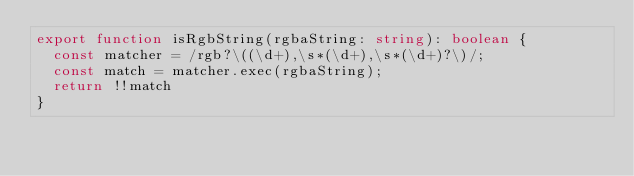<code> <loc_0><loc_0><loc_500><loc_500><_TypeScript_>export function isRgbString(rgbaString: string): boolean {
  const matcher = /rgb?\((\d+),\s*(\d+),\s*(\d+)?\)/;
  const match = matcher.exec(rgbaString);
  return !!match
}
</code> 